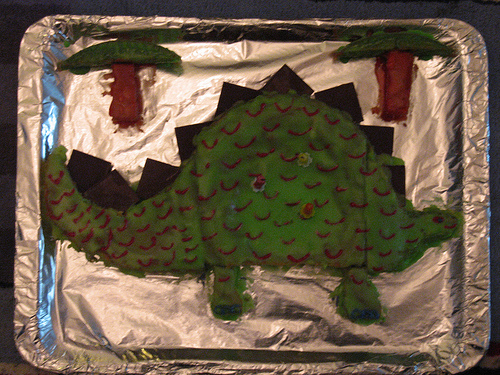<image>
Can you confirm if the tree is next to the tree? No. The tree is not positioned next to the tree. They are located in different areas of the scene. 